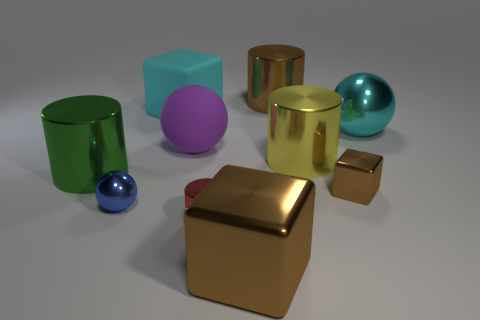Subtract 1 cylinders. How many cylinders are left? 3 Subtract all green blocks. Subtract all green cylinders. How many blocks are left? 3 Subtract all blocks. How many objects are left? 7 Subtract all large yellow metallic things. Subtract all small cubes. How many objects are left? 8 Add 9 brown shiny cylinders. How many brown shiny cylinders are left? 10 Add 4 large cyan blocks. How many large cyan blocks exist? 5 Subtract 0 green blocks. How many objects are left? 10 